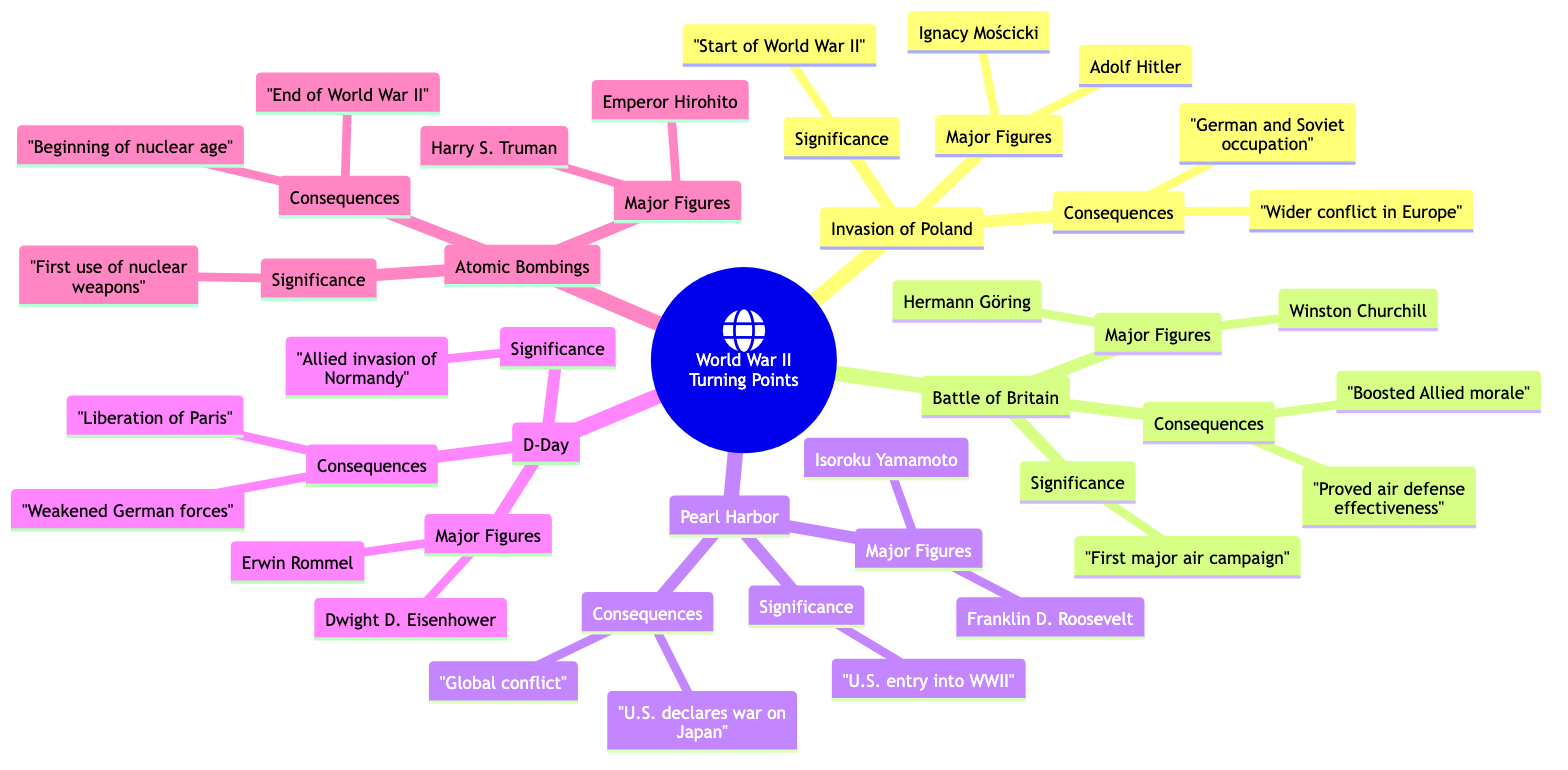What event marked the beginning of World War II? The diagram states that the Invasion of Poland was significant because it marked the beginning of World War II.
Answer: Invasion of Poland Who were the major figures involved in the Battle of Britain? The diagram lists the major figures in the Battle of Britain as Winston Churchill and Hermann Göring.
Answer: Winston Churchill and Hermann Göring What strategic outcome did the Battle of Britain achieve? According to the diagram, the significance of the Battle of Britain was that it prevented a German invasion of Britain, which was a key strategic outcome.
Answer: Prevented German invasion of Britain How did the Japanese attack on Pearl Harbor affect U.S. involvement in the war? The diagram indicates that the significance of Pearl Harbor was that it led to the U.S. entering World War II, demonstrating a direct impact on U.S. involvement in the conflict.
Answer: Led to U.S. entering World War II What was a major consequence of D-Day? Based on the diagram, a major consequence of D-Day was the liberation of Paris, which had a significant effect on the war's progression in Western Europe.
Answer: Liberation of Paris What was the result of the atomic bombings? The diagram explains that one of the consequences of the atomic bombings of Hiroshima and Nagasaki was the immediate end to World War II, which indicates a dramatic conclusion to the conflict.
Answer: Immediate end to World War II Which turning point involved the first use of nuclear weapons in war? The diagram identifies the atomic bombings of Hiroshima and Nagasaki as the event that involved the first use of nuclear weapons in war.
Answer: Atomic Bombings of Hiroshima and Nagasaki What effect did Pearl Harbor have on Germany and Italy's stance? The diagram shows that after Pearl Harbor, Germany and Italy declared war on the U.S., indicating a significant shift in the alliances and dynamics of the war.
Answer: Germany and Italy's declaration of war on the U.S Which event is associated with Dwight D. Eisenhower? The diagram states that Dwight D. Eisenhower was a major figure in the D-Day operation, linking him directly to this pivotal event in World War II.
Answer: D-Day 